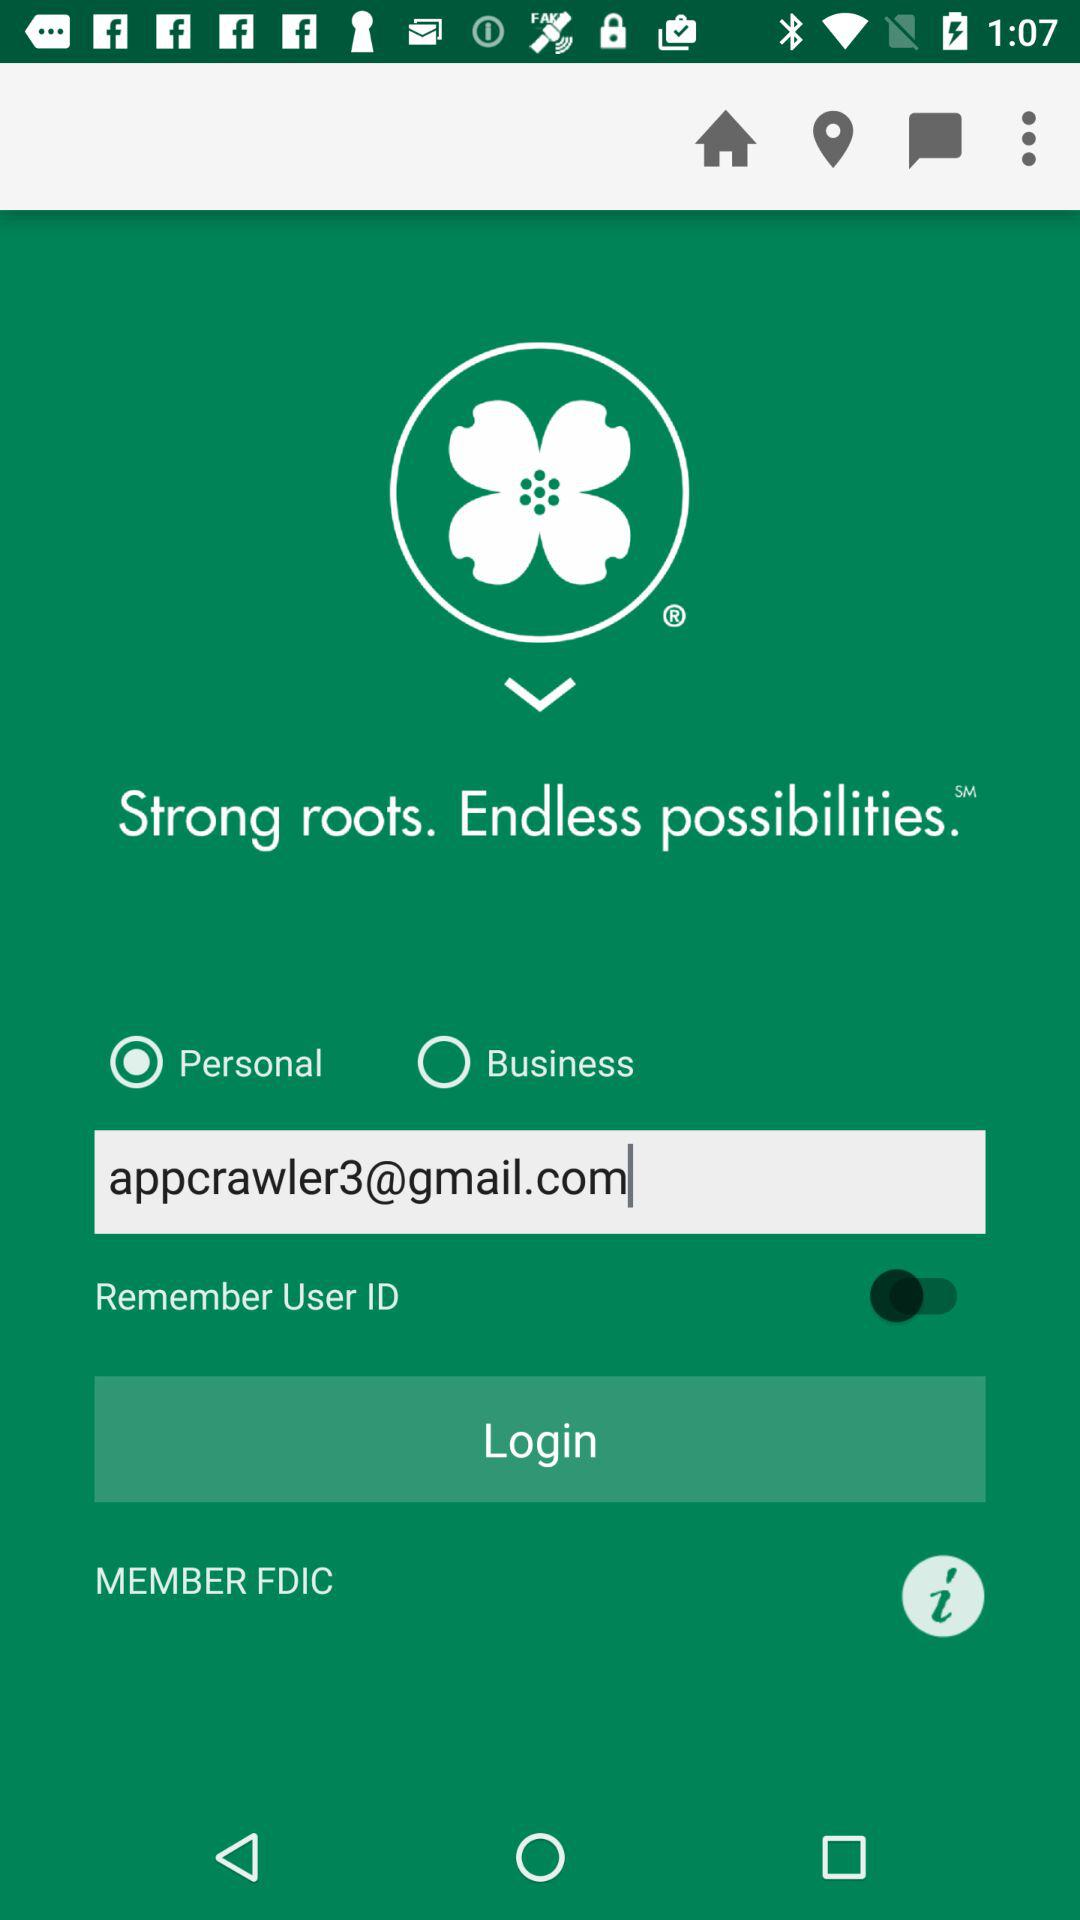What is the email address? The email address is appcrawler3@gmail.com. 